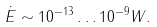<formula> <loc_0><loc_0><loc_500><loc_500>\dot { E } \sim 1 0 ^ { - 1 3 } \dots 1 0 ^ { - 9 } W .</formula> 